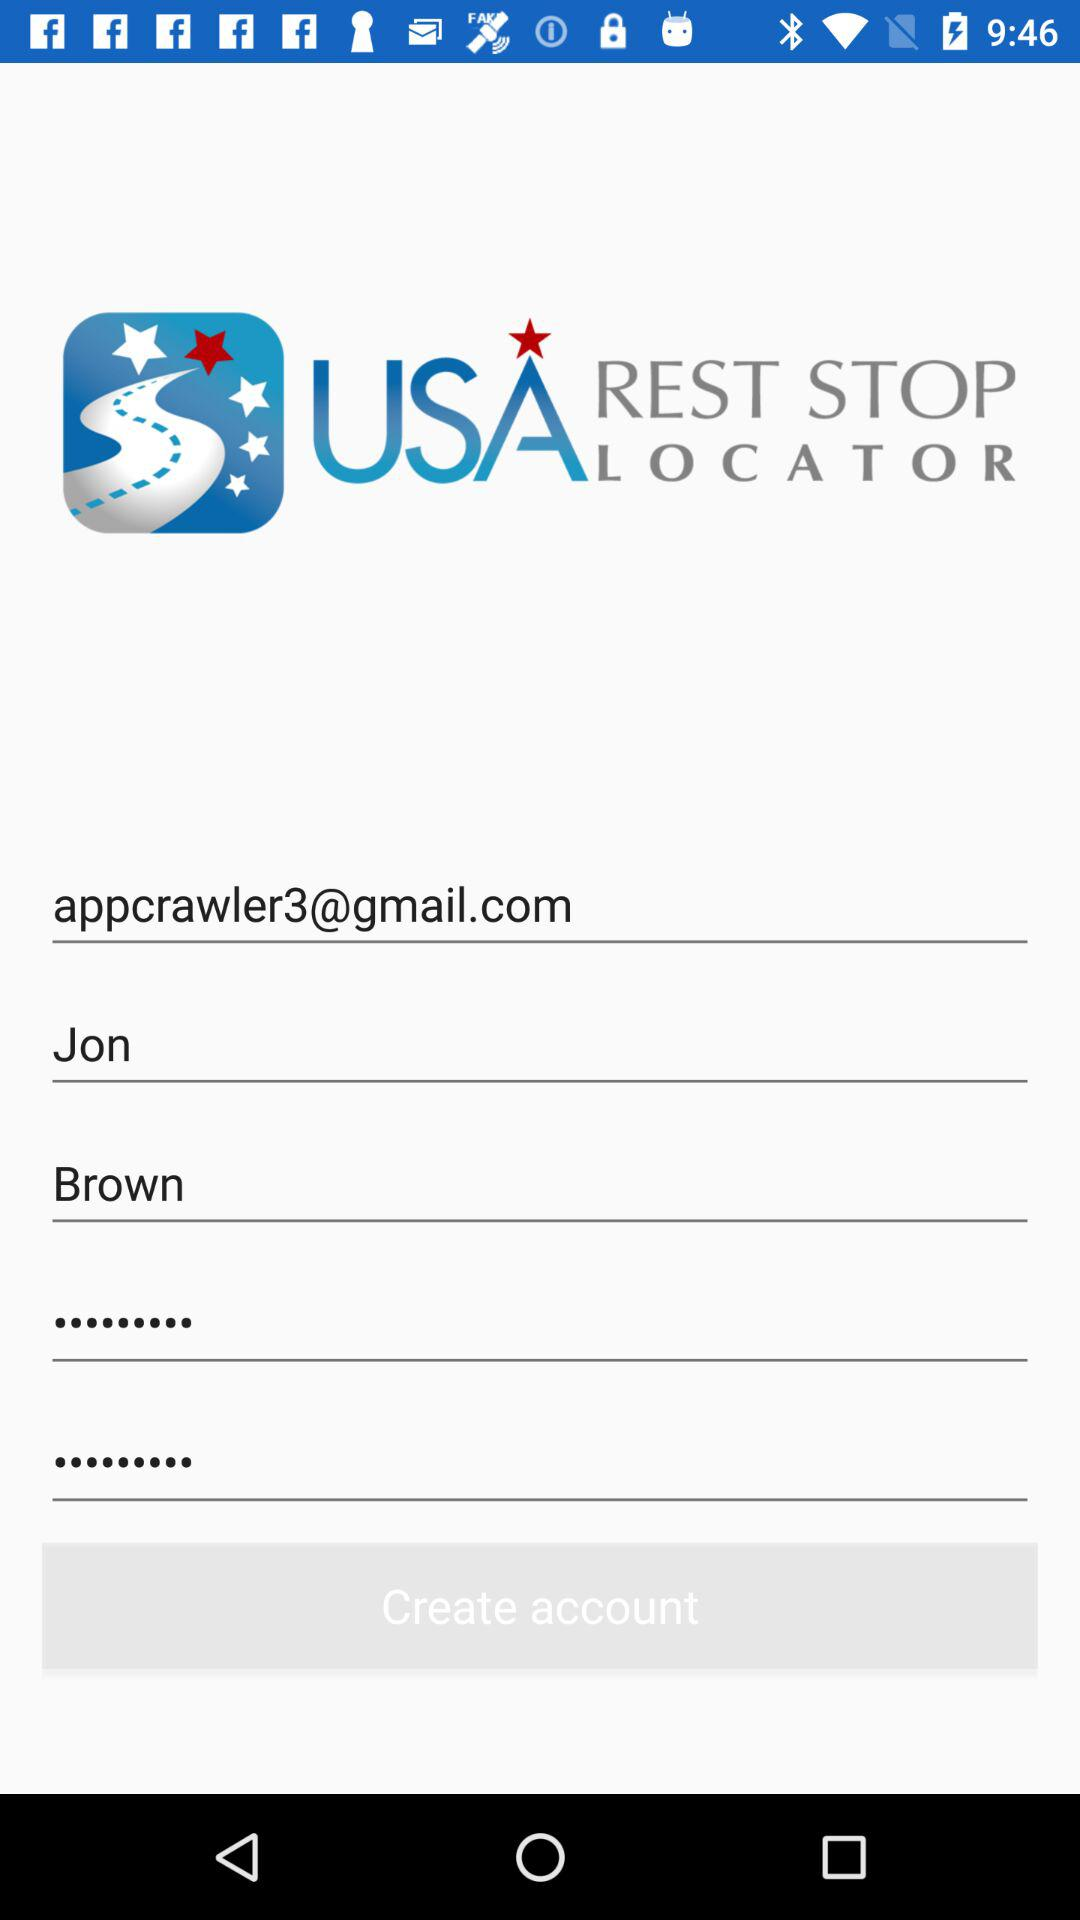What is the email address? The email address is appcrawler3@gmail.com. 